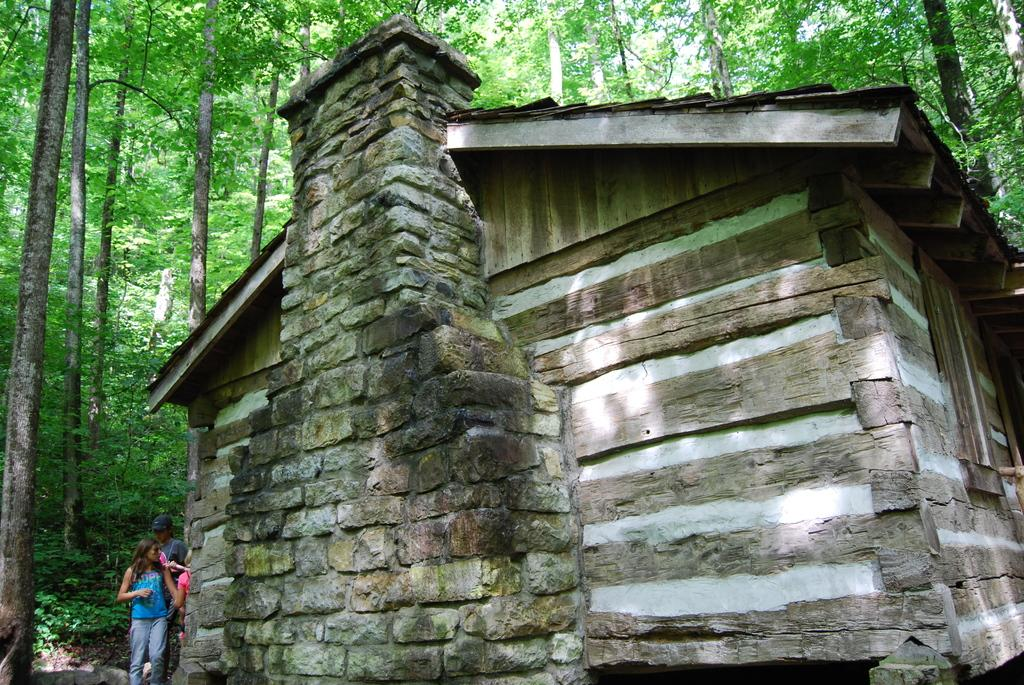What type of structure is present in the image? There is a house in the image. Can you describe the people in the image? The people are standing behind the house. What type of vegetation is visible in the image? There are plants and trees visible in the image. What type of care do the deer require in the image? There are no deer present in the image, so it is not possible to discuss their care. 